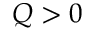<formula> <loc_0><loc_0><loc_500><loc_500>Q > 0</formula> 